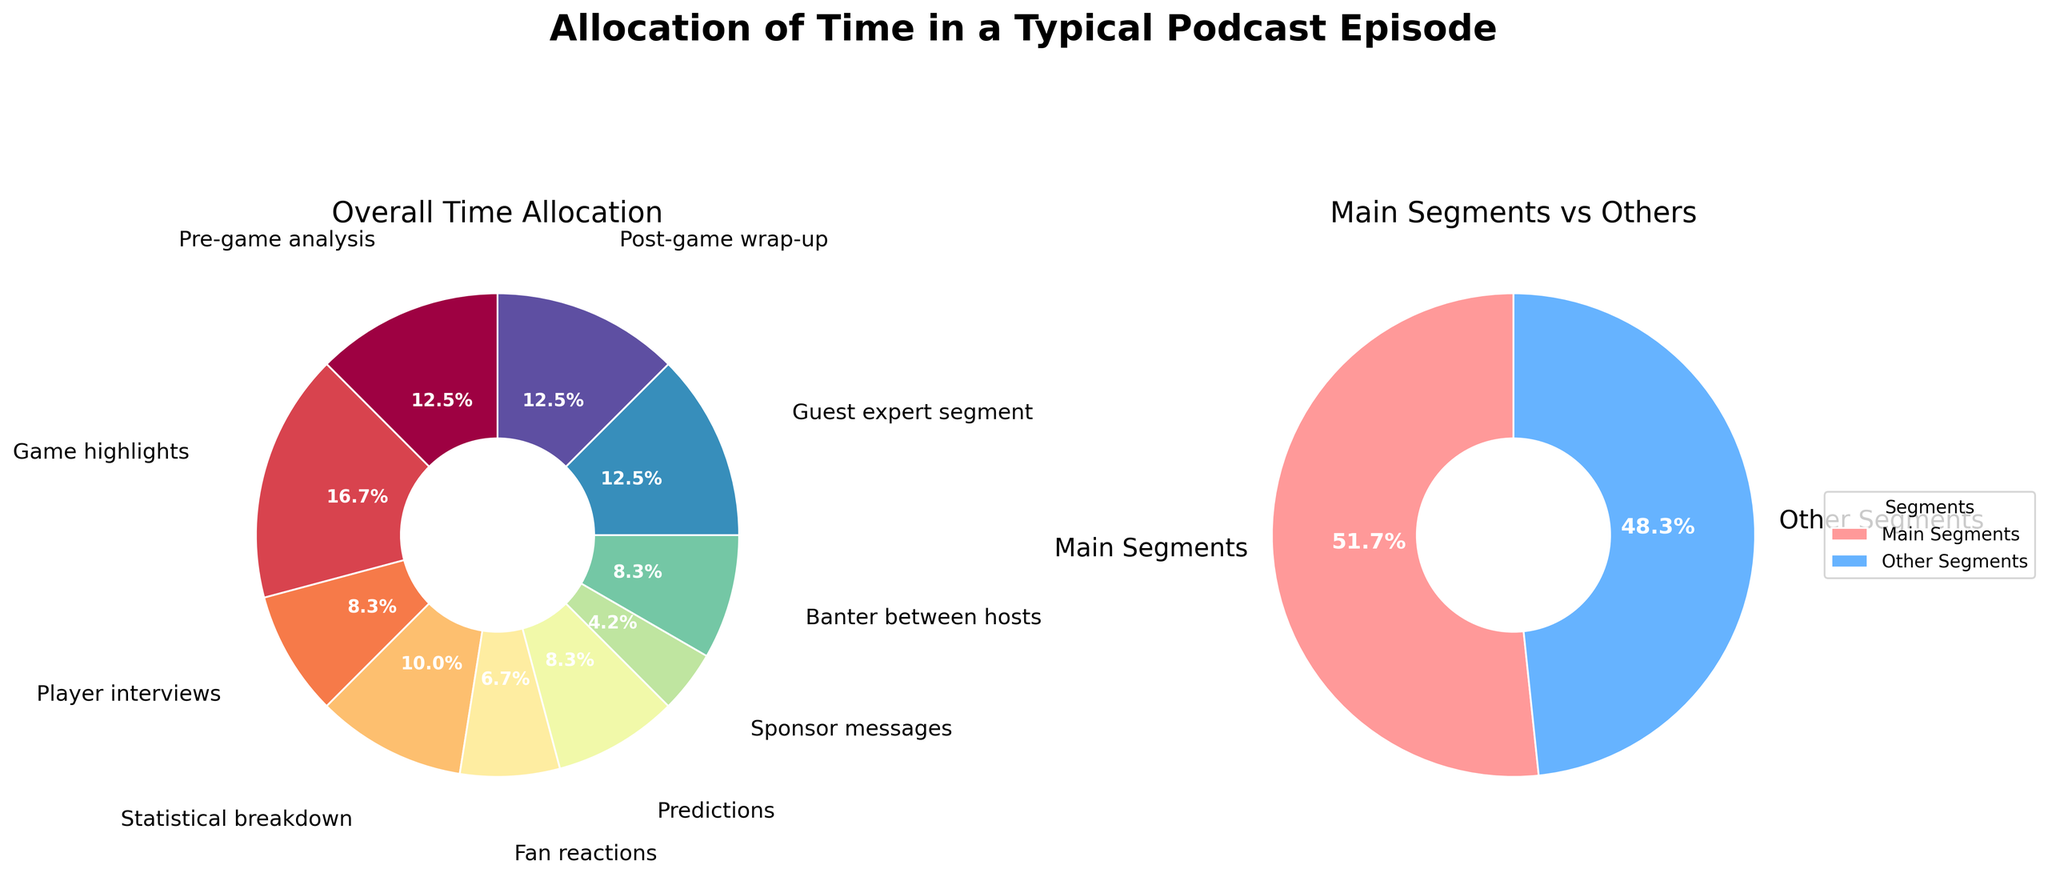What's the most allocated segment during a typical podcast episode based on the pie chart? The pie chart shows various segments with their corresponding percentages of time allocation. The largest slice represents the segment with the highest time allocation.
Answer: Game highlights How many minutes are allocated to the "Main Segments" category in the second pie chart? The second pie chart has two segments: "Main Segments" and "Other Segments." To find the "Main Segments" allocation, sum up the time from the provided data for pre-game analysis, game highlights, statistical breakdown, and post-game wrap-up. These values are 15, 20, 12, and 15 minutes respectively. The total is 15 + 20 + 12 + 15 = 62 minutes.
Answer: 62 Which segments are colored red and blue in the "Main Segments vs Others" pie chart? Since the second pie chart distinguishes between "Main Segments" and "Other Segments" with colors red and blue respectively, identify the segments using these colors in the visual.
Answer: Main Segments (red), Other Segments (blue) What is the combined percentage of time allocated to "Pre-game analysis" and "Post-game wrap-up"? Locate the two segments in the first pie chart and add their percentages: 15% (Pre-game analysis) + 15% (Post-game wrap-up) = 30%.
Answer: 30% How does the percentage time spent on "Guest expert segment" compare to "Fan reactions"? The first pie chart shows the individual segment percentages. "Guest expert segment" is 15%, and "Fan reactions" is 8%. Compare these percentages.
Answer: "Guest expert segment" has a higher percentage than "Fan reactions." What is the smallest segment in terms of time allocation, and how many minutes does it get? The pie chart identifies the smallest slices representing the time allocation per segment. The smallest segment is "Sponsor messages" with its respective time in the data table.
Answer: Sponsor messages, 5 minutes 